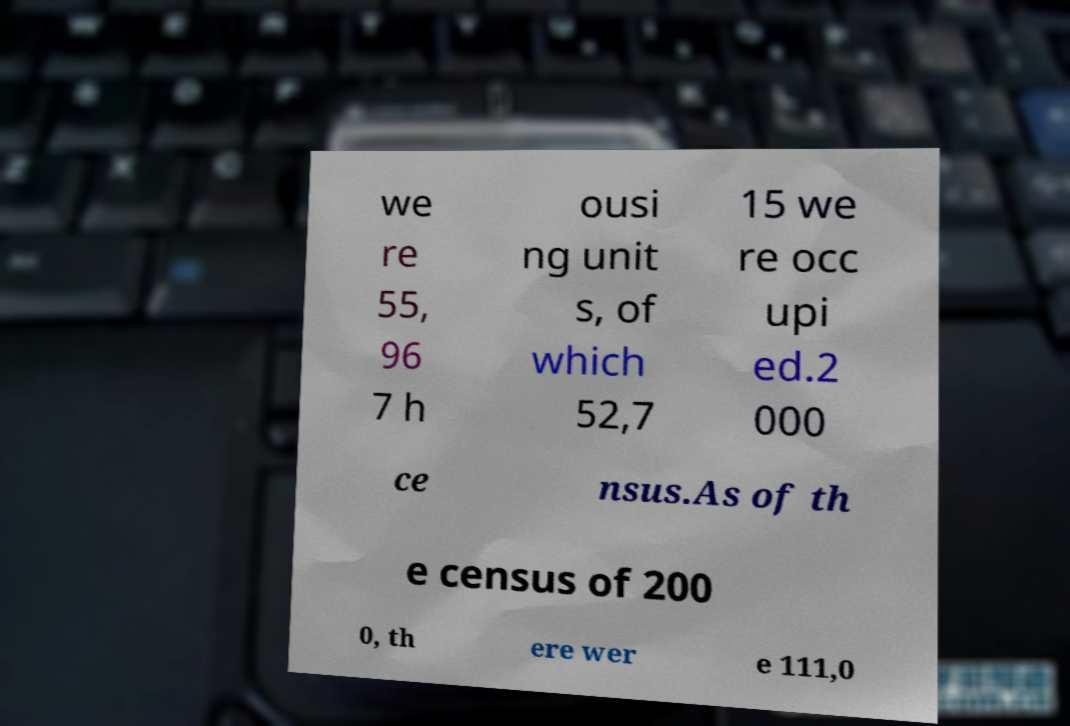Please read and relay the text visible in this image. What does it say? we re 55, 96 7 h ousi ng unit s, of which 52,7 15 we re occ upi ed.2 000 ce nsus.As of th e census of 200 0, th ere wer e 111,0 